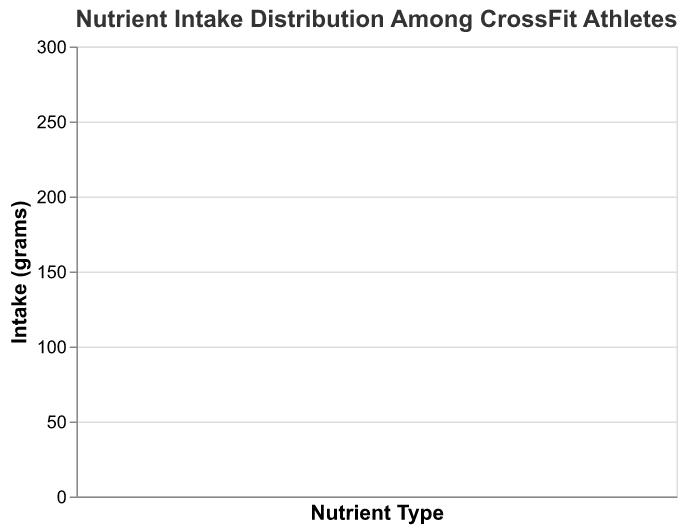How many main nutrient types are displayed in the box plot? The figure has an x-axis representing nutrient types. There are three distinct nutrient types labeled on the x-axis: Protein, Carbs, and Fats.
Answer: Three What is the maximum protein intake among the athletes? The box plot shows the maximum value on the whisker for Protein, and one of the scatter points also might be close to or at this value. By referring to the top of the whisker or the highest scatter point within the Protein section, you can determine that the maximum protein intake is 180 grams.
Answer: 180 grams Which dietary preference group has the highest carbohydrate intake? Individual points within the Carbs boxplot can be identified based on different colors representing dietary preferences. The highest point for carbohydrate intake is 280 grams, associated with the 'Moderate Carb' dietary preference.
Answer: Moderate Carb What is the median fat intake? The median is marked by a line inside the boxplot for Fats. By observing the middle line in the Fats box plot section, the median fat intake is approximately 75 grams.
Answer: 75 grams How many athletes follow a High Fats diet? Each scatter point representing athletes can be identified by hovering over or looking at the color legend. High Fats dietary preference points are highlighted twice, showing two athletes under this category.
Answer: Two Compare the median protein intake with the median carbohydrate intake. Which one is higher? Locate the median lines inside the boxes for both Protein and Carbs. The median for Protein is slightly less than the median for Carbs. The boxplot’s median line for Carbs is higher.
Answer: Carbs What is the range of fat intake for the athletes? The range is the difference between the highest and lowest points in the fats boxplot. The highest observed fat intake is 95 grams and the lowest is 50 grams. So, the range is 95 - 50.
Answer: 45 grams Identify the dietary preference with the widest distribution range for Protein intake. The range within the nutrient type can be determined by the length of the boxplot's whiskers. For Protein, it is seen that 'High Fats' preference shows a wider spread from 170 to 180 grams, compared to other dietary preferences.
Answer: High Fats What is the interquartile range (IQR) for carbohydrate intake? The IQR is the distance between the first quartile (25th percentile) and the third quartile (75th percentile). By observing the extent of the box (which marks the IQR) in the Carbs section, the IQR appears to range from ~220 grams to ~250 grams. Thus, IQR is 250 - 220.
Answer: 30 grams 